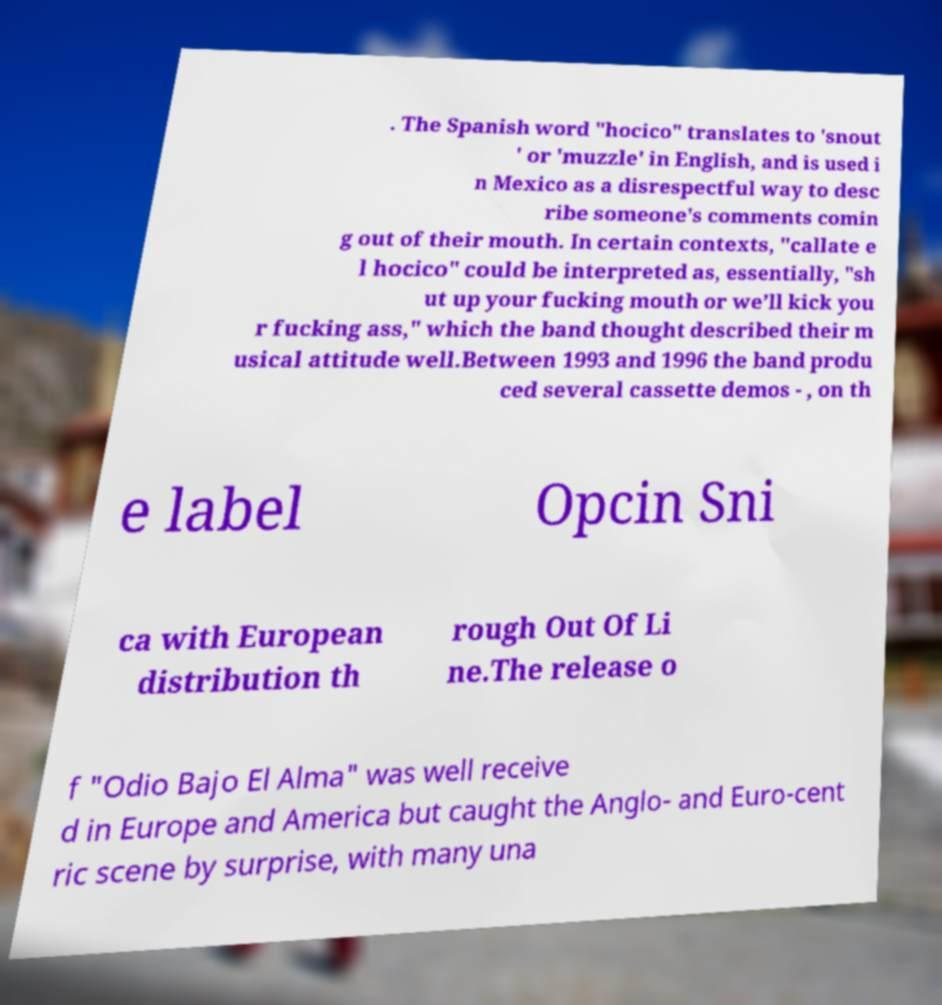I need the written content from this picture converted into text. Can you do that? . The Spanish word "hocico" translates to 'snout ' or 'muzzle' in English, and is used i n Mexico as a disrespectful way to desc ribe someone's comments comin g out of their mouth. In certain contexts, "callate e l hocico" could be interpreted as, essentially, "sh ut up your fucking mouth or we’ll kick you r fucking ass," which the band thought described their m usical attitude well.Between 1993 and 1996 the band produ ced several cassette demos - , on th e label Opcin Sni ca with European distribution th rough Out Of Li ne.The release o f "Odio Bajo El Alma" was well receive d in Europe and America but caught the Anglo- and Euro-cent ric scene by surprise, with many una 